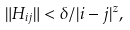Convert formula to latex. <formula><loc_0><loc_0><loc_500><loc_500>\| H _ { i j } \| < \delta / | i - j | ^ { z } ,</formula> 